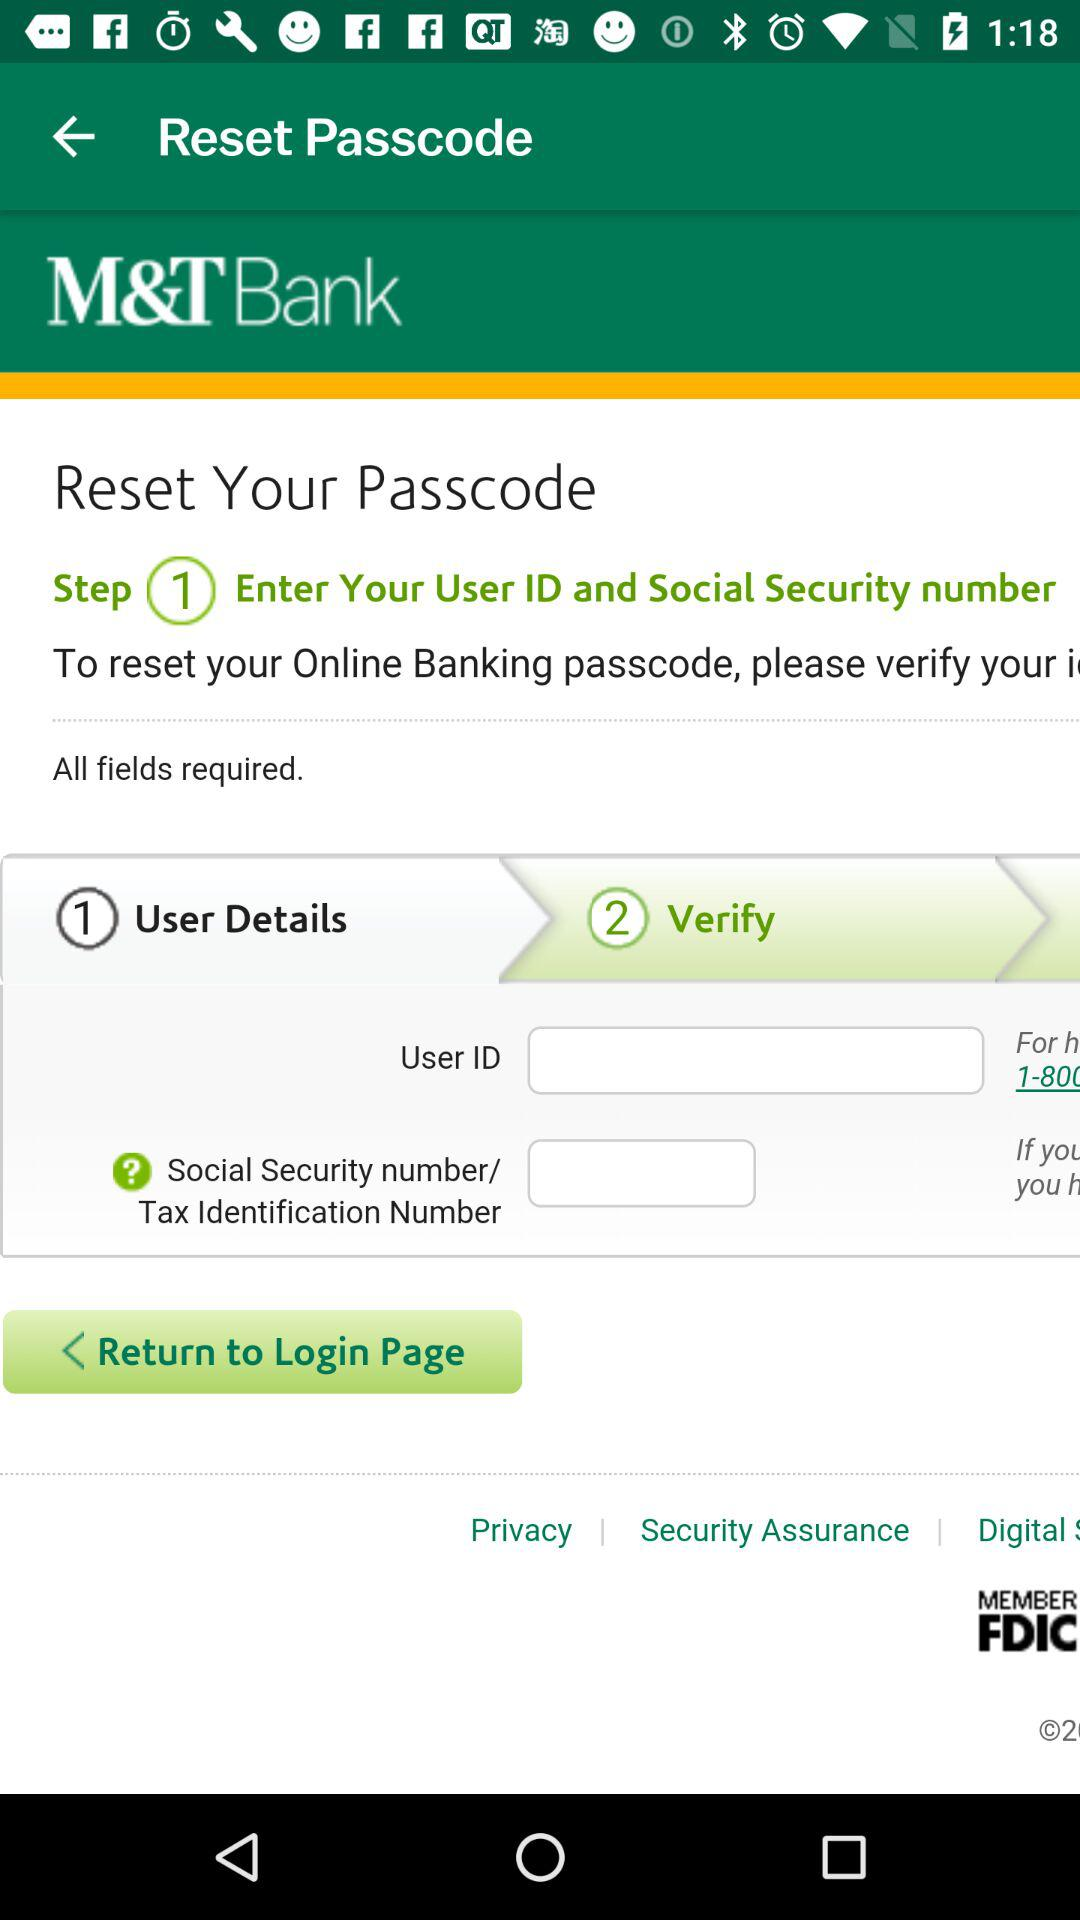What is step 2 for resetting a password? The step 2 is "Verify". 